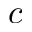Convert formula to latex. <formula><loc_0><loc_0><loc_500><loc_500>c</formula> 